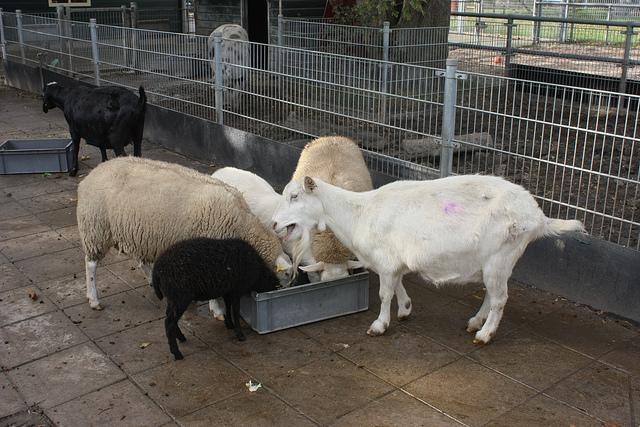Why are the animals crowded around the bucket? eating 